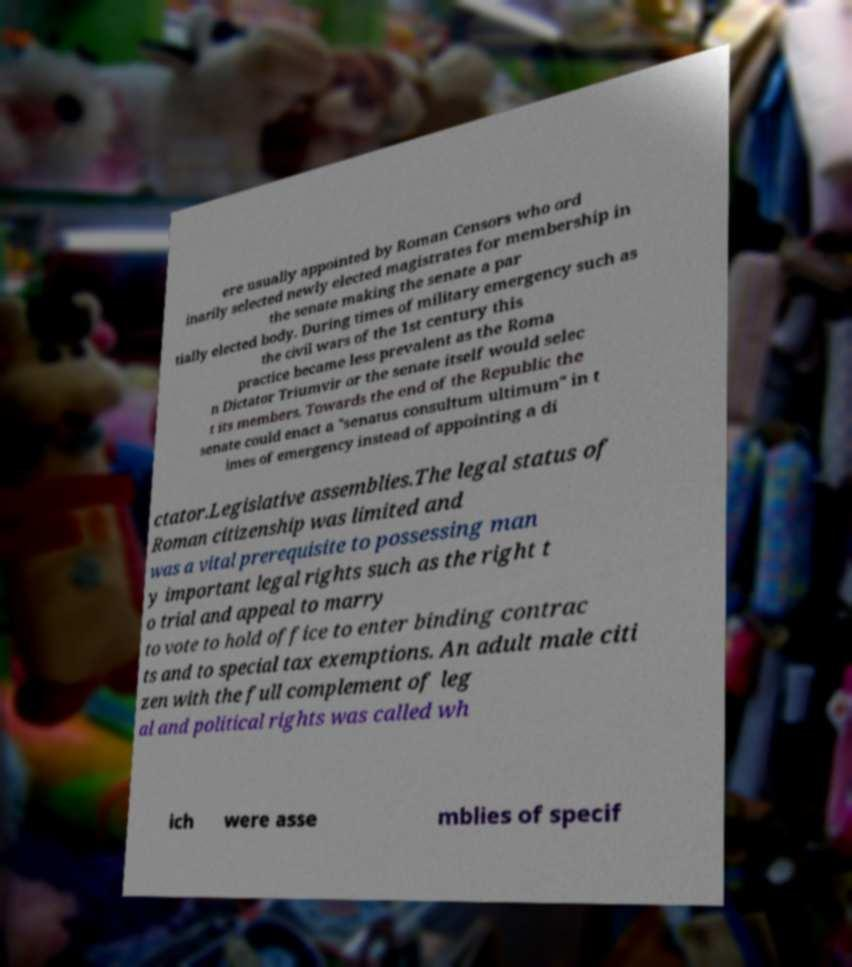I need the written content from this picture converted into text. Can you do that? ere usually appointed by Roman Censors who ord inarily selected newly elected magistrates for membership in the senate making the senate a par tially elected body. During times of military emergency such as the civil wars of the 1st century this practice became less prevalent as the Roma n Dictator Triumvir or the senate itself would selec t its members. Towards the end of the Republic the senate could enact a "senatus consultum ultimum" in t imes of emergency instead of appointing a di ctator.Legislative assemblies.The legal status of Roman citizenship was limited and was a vital prerequisite to possessing man y important legal rights such as the right t o trial and appeal to marry to vote to hold office to enter binding contrac ts and to special tax exemptions. An adult male citi zen with the full complement of leg al and political rights was called wh ich were asse mblies of specif 